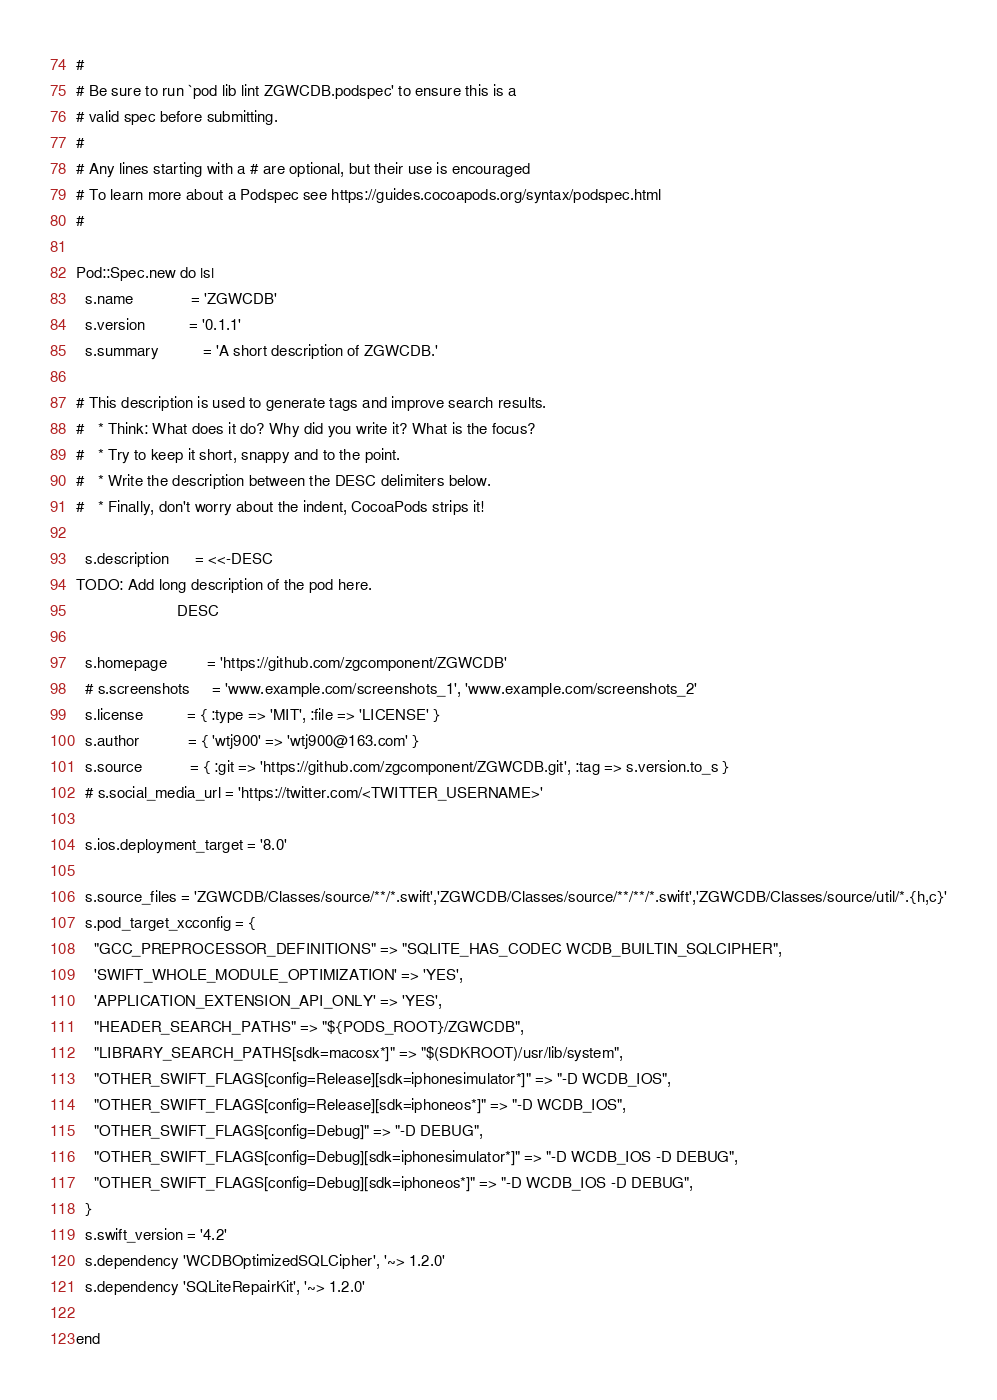<code> <loc_0><loc_0><loc_500><loc_500><_Ruby_>#
# Be sure to run `pod lib lint ZGWCDB.podspec' to ensure this is a
# valid spec before submitting.
#
# Any lines starting with a # are optional, but their use is encouraged
# To learn more about a Podspec see https://guides.cocoapods.org/syntax/podspec.html
#

Pod::Spec.new do |s|
  s.name             = 'ZGWCDB'
  s.version          = '0.1.1'
  s.summary          = 'A short description of ZGWCDB.'

# This description is used to generate tags and improve search results.
#   * Think: What does it do? Why did you write it? What is the focus?
#   * Try to keep it short, snappy and to the point.
#   * Write the description between the DESC delimiters below.
#   * Finally, don't worry about the indent, CocoaPods strips it!

  s.description      = <<-DESC
TODO: Add long description of the pod here.
                       DESC

  s.homepage         = 'https://github.com/zgcomponent/ZGWCDB'
  # s.screenshots     = 'www.example.com/screenshots_1', 'www.example.com/screenshots_2'
  s.license          = { :type => 'MIT', :file => 'LICENSE' }
  s.author           = { 'wtj900' => 'wtj900@163.com' }
  s.source           = { :git => 'https://github.com/zgcomponent/ZGWCDB.git', :tag => s.version.to_s }
  # s.social_media_url = 'https://twitter.com/<TWITTER_USERNAME>'

  s.ios.deployment_target = '8.0'

  s.source_files = 'ZGWCDB/Classes/source/**/*.swift','ZGWCDB/Classes/source/**/**/*.swift','ZGWCDB/Classes/source/util/*.{h,c}'
  s.pod_target_xcconfig = {
    "GCC_PREPROCESSOR_DEFINITIONS" => "SQLITE_HAS_CODEC WCDB_BUILTIN_SQLCIPHER",
    'SWIFT_WHOLE_MODULE_OPTIMIZATION' => 'YES',
    'APPLICATION_EXTENSION_API_ONLY' => 'YES',
    "HEADER_SEARCH_PATHS" => "${PODS_ROOT}/ZGWCDB",
    "LIBRARY_SEARCH_PATHS[sdk=macosx*]" => "$(SDKROOT)/usr/lib/system",
    "OTHER_SWIFT_FLAGS[config=Release][sdk=iphonesimulator*]" => "-D WCDB_IOS",
    "OTHER_SWIFT_FLAGS[config=Release][sdk=iphoneos*]" => "-D WCDB_IOS",
    "OTHER_SWIFT_FLAGS[config=Debug]" => "-D DEBUG",
    "OTHER_SWIFT_FLAGS[config=Debug][sdk=iphonesimulator*]" => "-D WCDB_IOS -D DEBUG",
    "OTHER_SWIFT_FLAGS[config=Debug][sdk=iphoneos*]" => "-D WCDB_IOS -D DEBUG",
  }
  s.swift_version = '4.2'
  s.dependency 'WCDBOptimizedSQLCipher', '~> 1.2.0'
  s.dependency 'SQLiteRepairKit', '~> 1.2.0'

end
</code> 